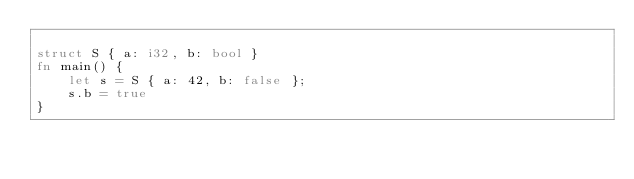<code> <loc_0><loc_0><loc_500><loc_500><_Rust_>
struct S { a: i32, b: bool }
fn main() {
    let s = S { a: 42, b: false };
    s.b = true
}
</code> 